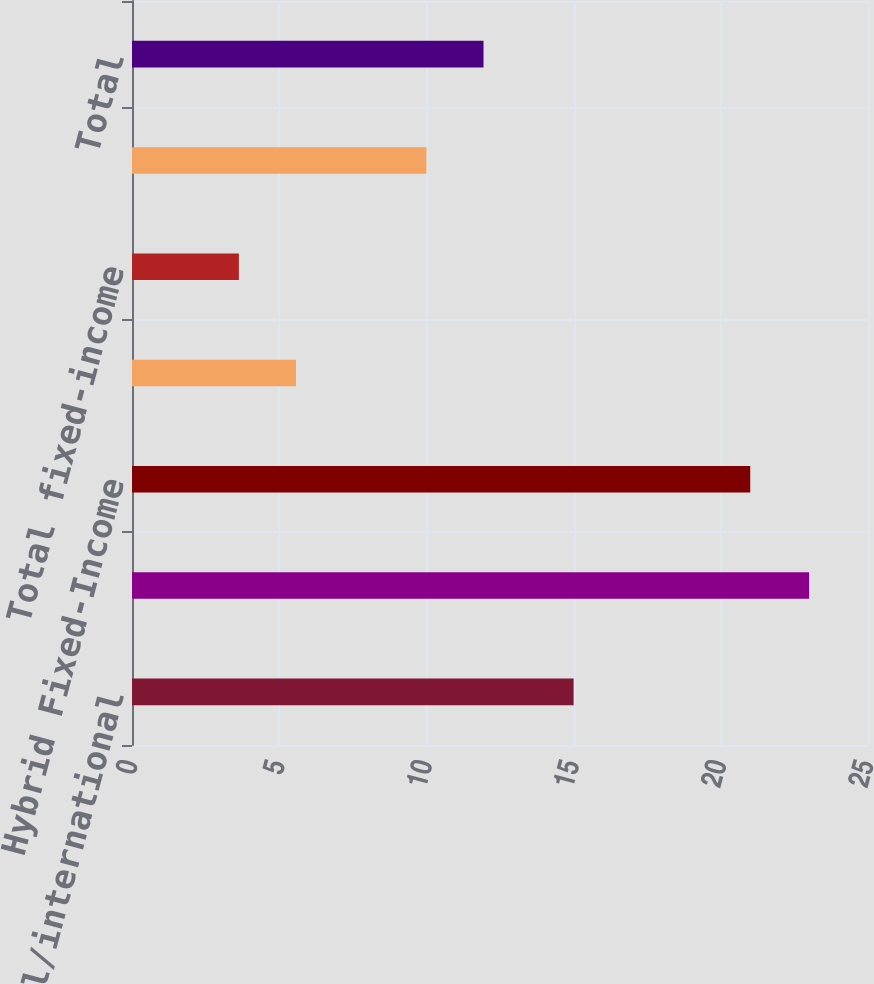Convert chart to OTSL. <chart><loc_0><loc_0><loc_500><loc_500><bar_chart><fcel>Global/international<fcel>United States Total equity<fcel>Hybrid Fixed-Income<fcel>United States<fcel>Total fixed-income<fcel>Cash Management<fcel>Total<nl><fcel>15<fcel>23<fcel>21<fcel>5.57<fcel>3.63<fcel>10<fcel>11.94<nl></chart> 